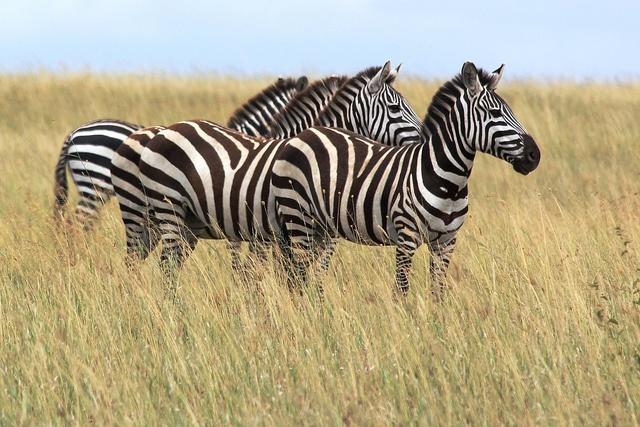Describe the objects in this image and their specific colors. I can see zebra in white, black, gray, darkgray, and lightgray tones, zebra in white, black, lightgray, and gray tones, zebra in white, black, gray, lightgray, and tan tones, and zebra in white, black, gray, tan, and darkgray tones in this image. 